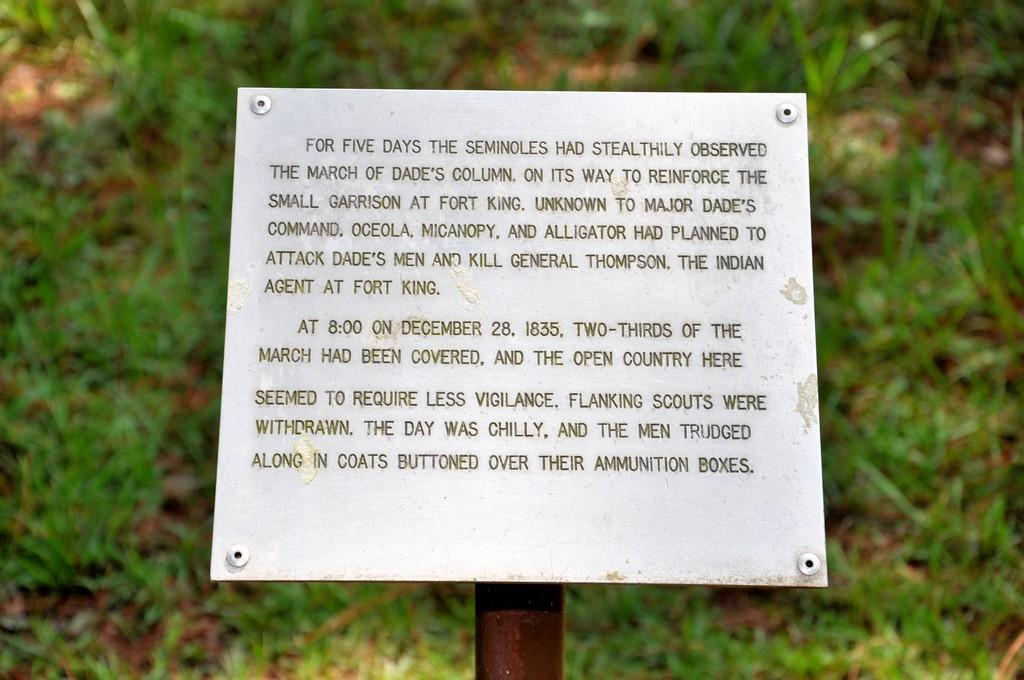What is the main object in the image? There is a board in the image. What is written or displayed on the board? There is text on the board. What type of natural environment is visible in the background of the image? There is grass visible in the background of the image. Can you see a boy playing with a feather in the image? There is no boy or feather present in the image; it only features a board with text and grass in the background. 